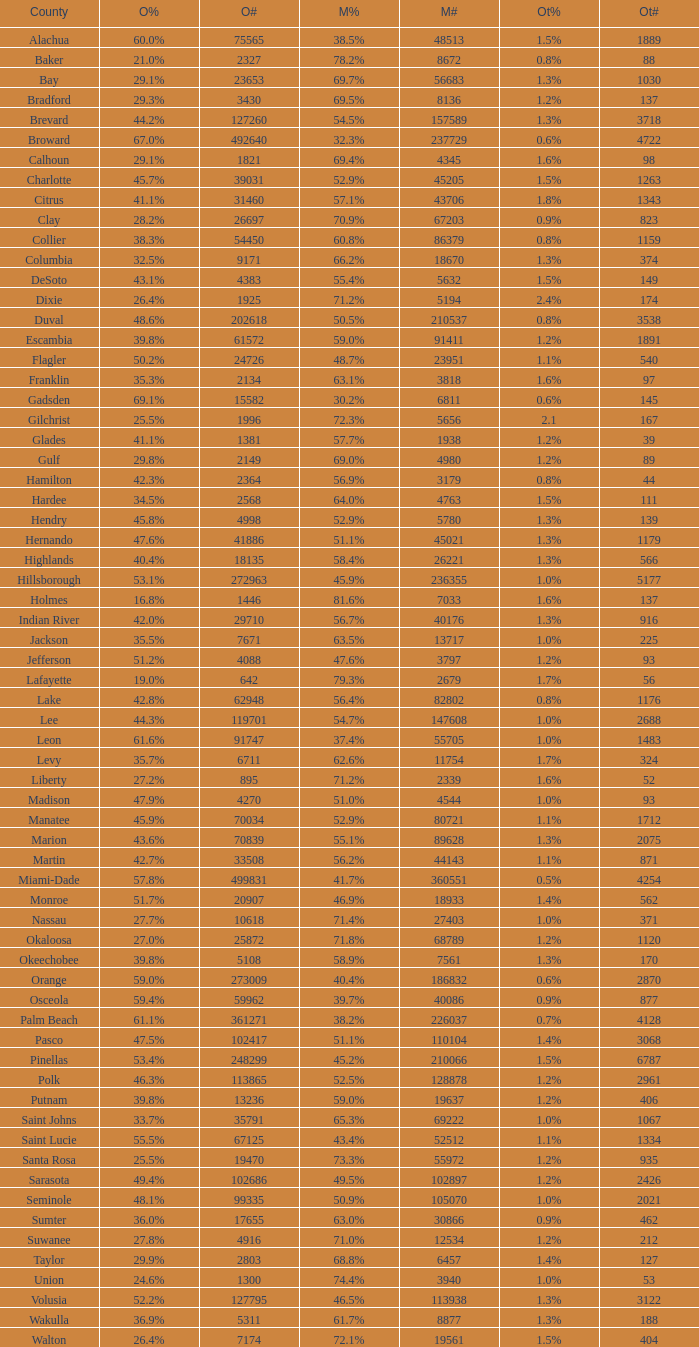What were the number of voters McCain had when Obama had 895? 2339.0. 